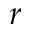Convert formula to latex. <formula><loc_0><loc_0><loc_500><loc_500>r</formula> 